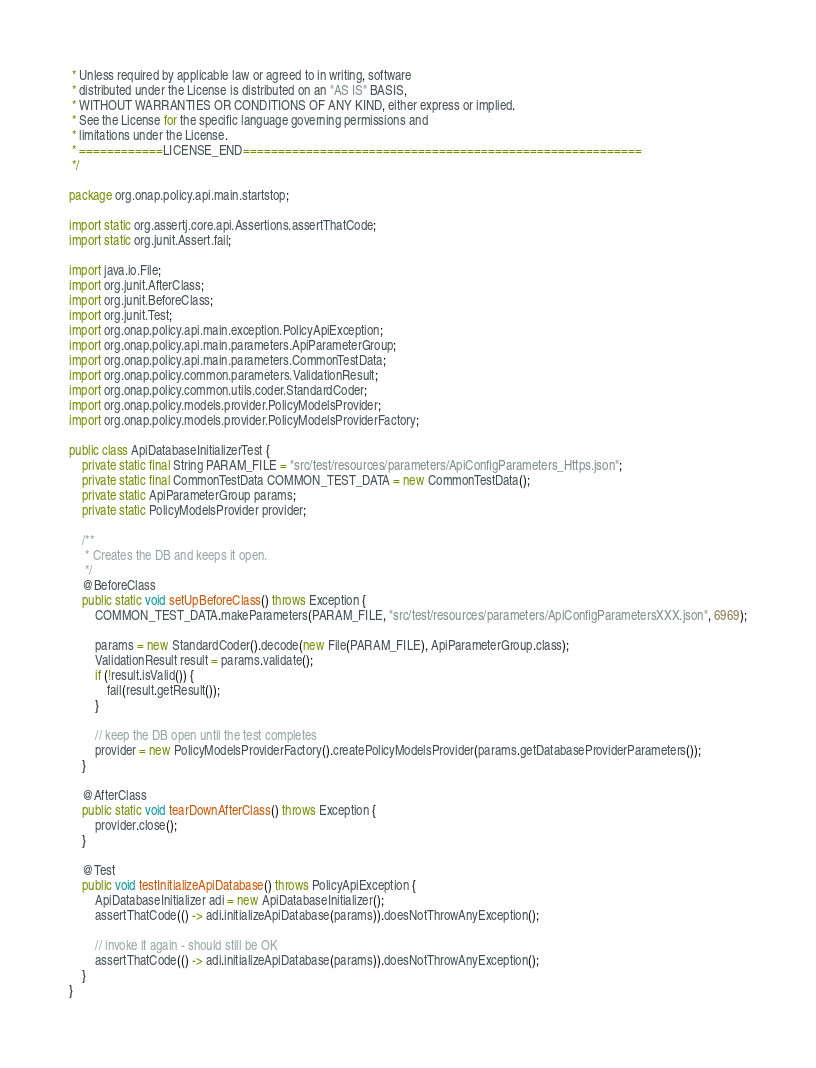<code> <loc_0><loc_0><loc_500><loc_500><_Java_> * Unless required by applicable law or agreed to in writing, software
 * distributed under the License is distributed on an "AS IS" BASIS,
 * WITHOUT WARRANTIES OR CONDITIONS OF ANY KIND, either express or implied.
 * See the License for the specific language governing permissions and
 * limitations under the License.
 * ============LICENSE_END=========================================================
 */

package org.onap.policy.api.main.startstop;

import static org.assertj.core.api.Assertions.assertThatCode;
import static org.junit.Assert.fail;

import java.io.File;
import org.junit.AfterClass;
import org.junit.BeforeClass;
import org.junit.Test;
import org.onap.policy.api.main.exception.PolicyApiException;
import org.onap.policy.api.main.parameters.ApiParameterGroup;
import org.onap.policy.api.main.parameters.CommonTestData;
import org.onap.policy.common.parameters.ValidationResult;
import org.onap.policy.common.utils.coder.StandardCoder;
import org.onap.policy.models.provider.PolicyModelsProvider;
import org.onap.policy.models.provider.PolicyModelsProviderFactory;

public class ApiDatabaseInitializerTest {
    private static final String PARAM_FILE = "src/test/resources/parameters/ApiConfigParameters_Https.json";
    private static final CommonTestData COMMON_TEST_DATA = new CommonTestData();
    private static ApiParameterGroup params;
    private static PolicyModelsProvider provider;

    /**
     * Creates the DB and keeps it open.
     */
    @BeforeClass
    public static void setUpBeforeClass() throws Exception {
        COMMON_TEST_DATA.makeParameters(PARAM_FILE, "src/test/resources/parameters/ApiConfigParametersXXX.json", 6969);

        params = new StandardCoder().decode(new File(PARAM_FILE), ApiParameterGroup.class);
        ValidationResult result = params.validate();
        if (!result.isValid()) {
            fail(result.getResult());
        }

        // keep the DB open until the test completes
        provider = new PolicyModelsProviderFactory().createPolicyModelsProvider(params.getDatabaseProviderParameters());
    }

    @AfterClass
    public static void tearDownAfterClass() throws Exception {
        provider.close();
    }

    @Test
    public void testInitializeApiDatabase() throws PolicyApiException {
        ApiDatabaseInitializer adi = new ApiDatabaseInitializer();
        assertThatCode(() -> adi.initializeApiDatabase(params)).doesNotThrowAnyException();

        // invoke it again - should still be OK
        assertThatCode(() -> adi.initializeApiDatabase(params)).doesNotThrowAnyException();
    }
}
</code> 